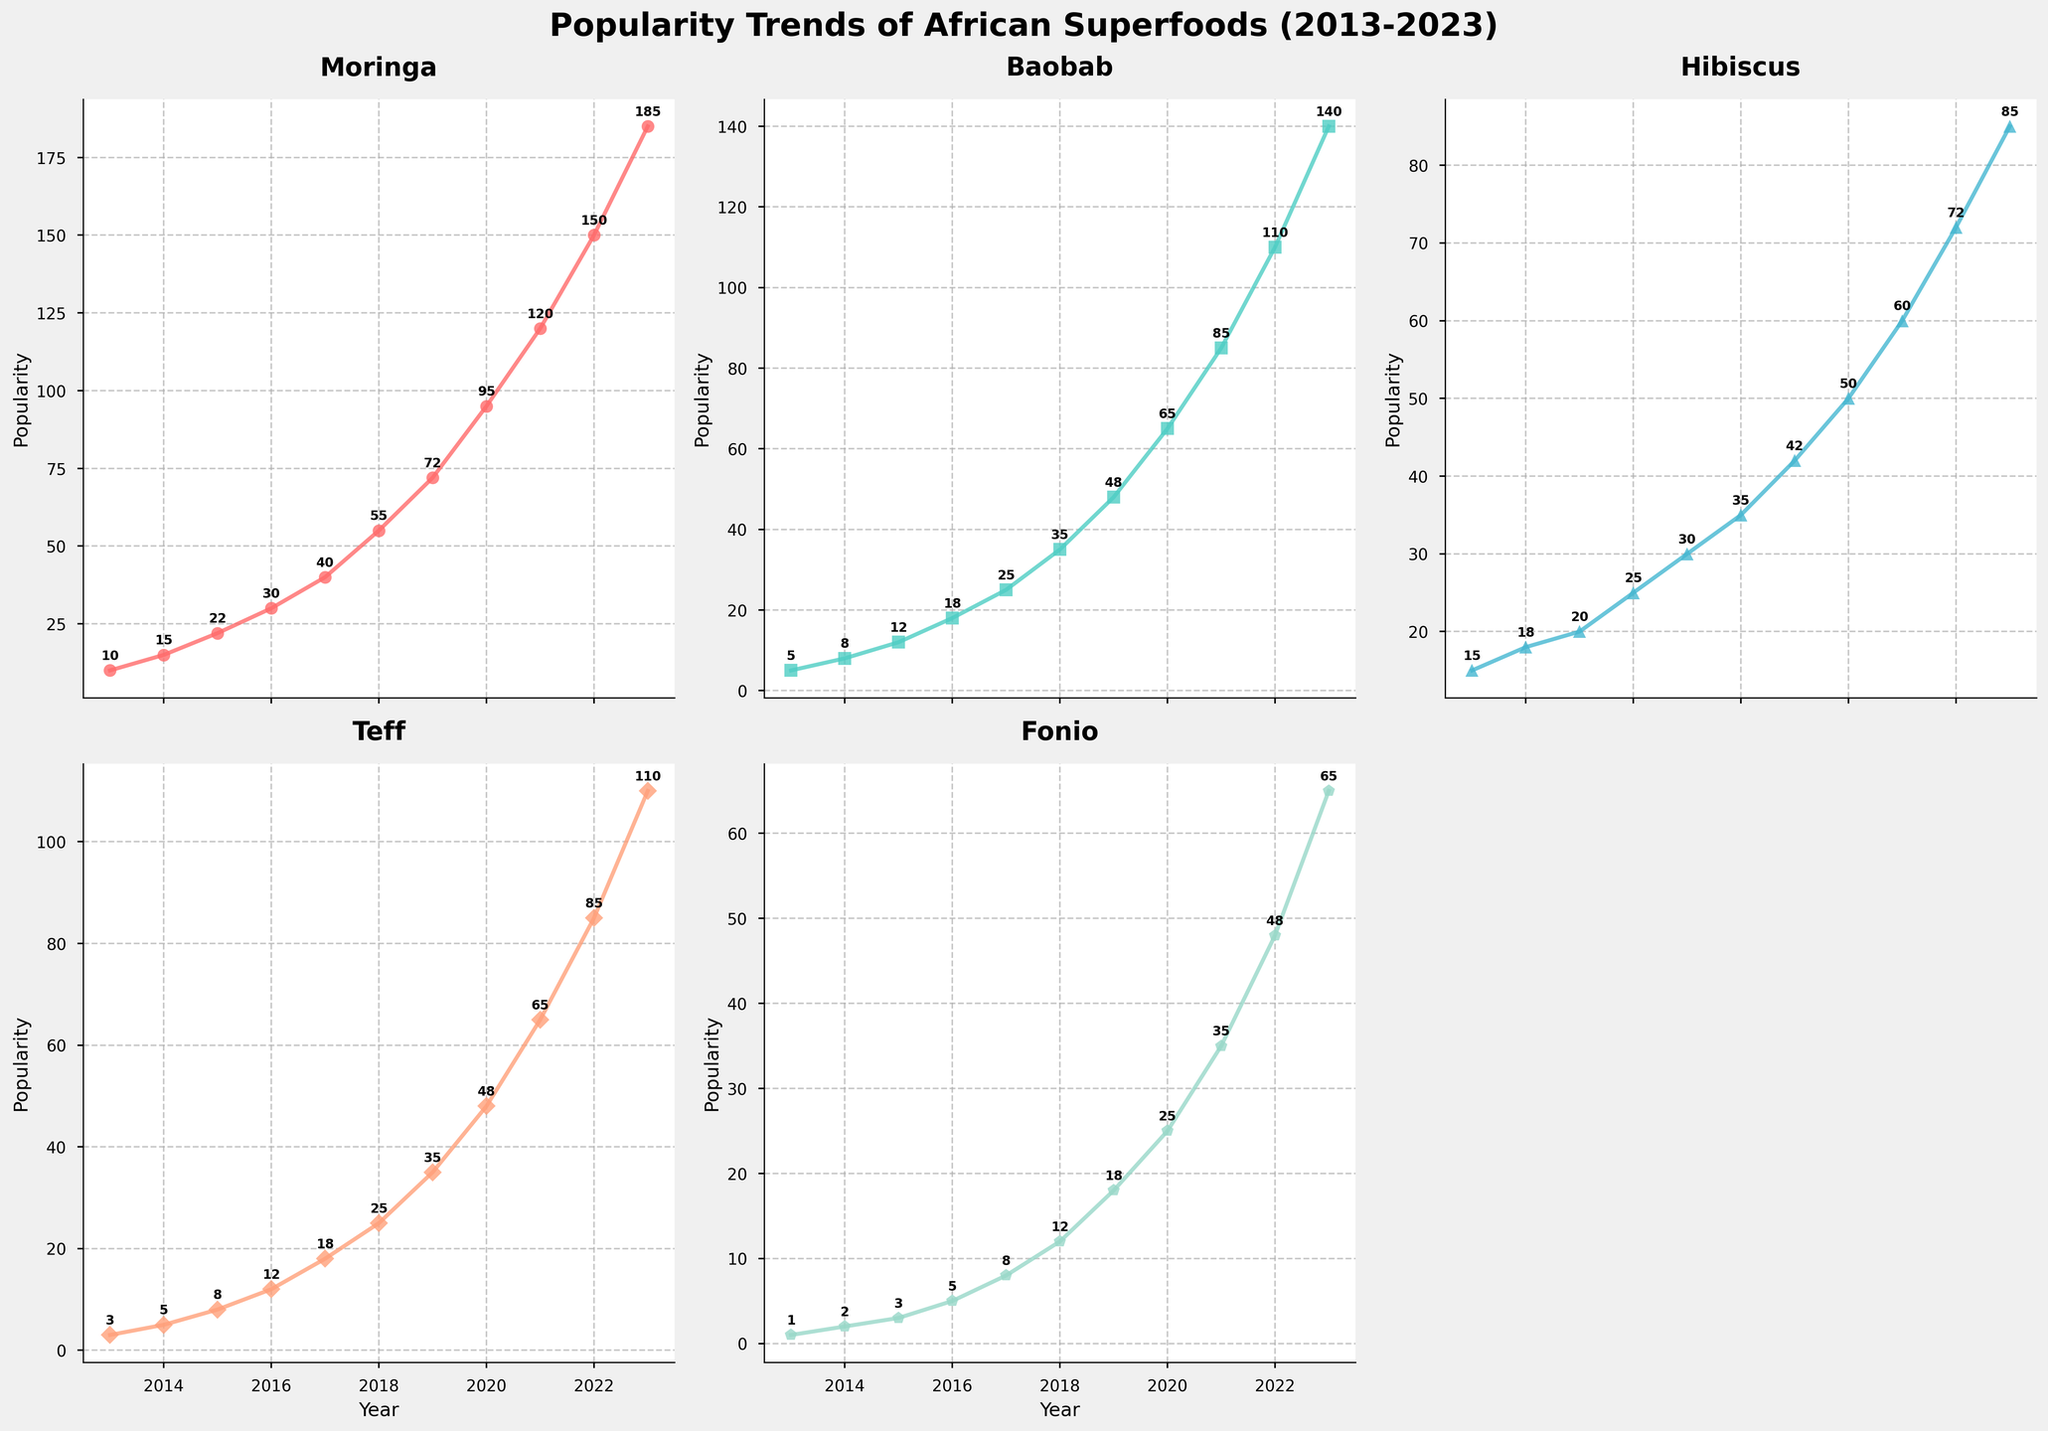Which superfood had the highest popularity in 2023? By examining the end points of all five lines in the figure for the year 2023, we can see that Moringa has the highest point at 185 compared to Baobab (140), Hibiscus (85), Teff (110), and Fonio (65).
Answer: Moringa How did the popularity of Teff change from 2016 to 2020? Check the values for Teff at the years 2016 and 2020. In 2016, it was 12, and in 2020, it increased to 48. The change can be calculated as 48 - 12.
Answer: Increased by 36 Compare the growth rate of Fonio and Hibiscus between 2015 and 2019. Calculate the growth for both Fonio and Hibiscus over the mentioned years. Fonio grew from 3 to 18 (18 - 3 = 15) and Hibiscus from 20 to 42 (42 - 20 = 22) over these years. Hibiscus had a higher growth rate.
Answer: Hibiscus grew faster Which superfood showed the most steady increase in popularity over the decade? By closely examining the trend lines for each superfood from 2013 to 2023, Moringa shows the most consistent upward trajectory without sudden spikes or drops compared to the other superfoods.
Answer: Moringa What is the average popularity of Baobab from 2013 to 2023? Sum the popularity values of Baobab for each year and divide by the number of years. The sum is 5 + 8 + 12 + 18 + 25 + 35 + 48 + 65 + 85 + 110 + 140 = 551. This sum divided by 11 years gives an average of 551 / 11.
Answer: 50.09 Between which years did Moringa see the highest growth in popularity? By analyzing the steepness of the Moringa line, the year-on-year increases are largest between 2019 and 2020, where it jumped from 72 to 95, and between 2022 and 2023, where it increased from 150 to 185. Compare the differences: 95 - 72 = 23 and 185 - 150 = 35. The highest growth was between 2022 and 2023.
Answer: 2022-2023 What is the difference in popularity between the most and least popular superfoods in 2023? Identify the popularity figures for the highest and lowest superfoods in 2023: Moringa (185) and Fonio (65). Subtract the smallest value from the largest: 185 - 65.
Answer: 120 By what percentage did the popularity of Hibiscus increase from 2013 to 2023? First, calculate the difference in popularity for Hibiscus from 2013 to 2023: 85 - 15 = 70. Next, divide this change by the 2013 value and multiply by 100 to find the percentage: (70 / 15) * 100 = 466.67%.
Answer: 466.67% What was the total popularity of all superfoods combined in 2019? Sum up the popularity figures for each superfood in 2019: 72 (Moringa) + 48 (Baobab) + 42 (Hibiscus) + 35 (Teff) + 18 (Fonio) = 215.
Answer: 215 Which years did Baobab overtake Hibiscus in popularity? Compare the trend lines for Baobab and Hibiscus year by year. Baobab overtakes Hibiscus in the year's 2021 (85 vs. 60), 2022 (110 vs. 72), and 2023 (140 vs. 85) as per the graph.
Answer: 2021, 2022, 2023 